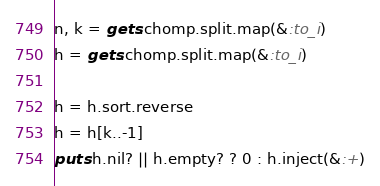Convert code to text. <code><loc_0><loc_0><loc_500><loc_500><_Ruby_>n, k = gets.chomp.split.map(&:to_i)
h = gets.chomp.split.map(&:to_i)

h = h.sort.reverse
h = h[k..-1]
puts h.nil? || h.empty? ? 0 : h.inject(&:+)
</code> 